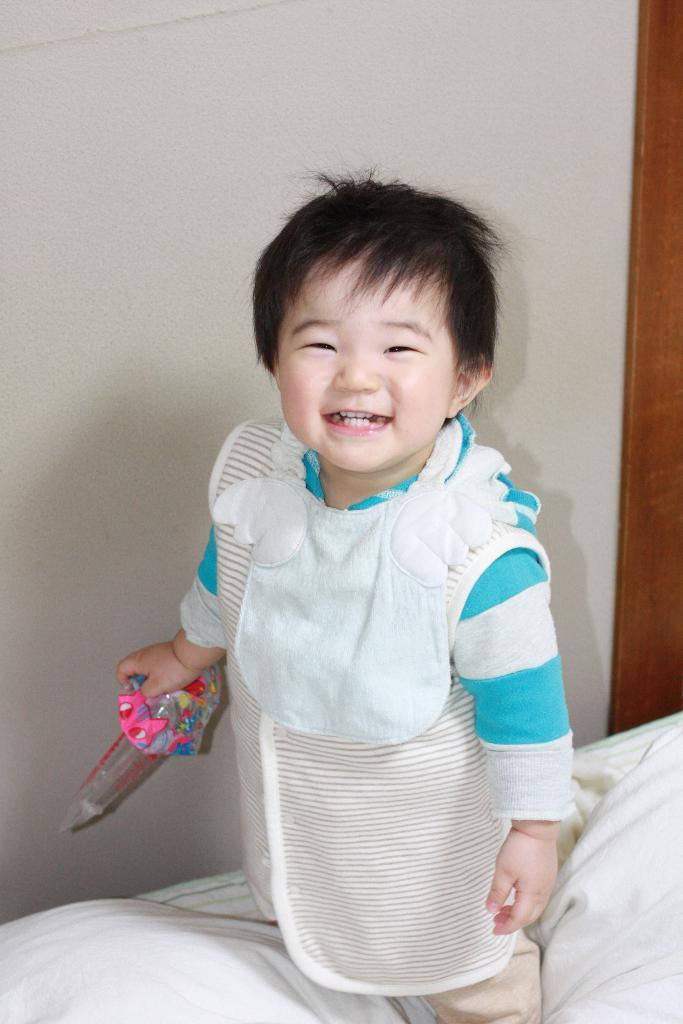Describe this image in one or two sentences. In this image there is a kid holding a toy and standing on the blanket of the bed, and in the background there is wall. 